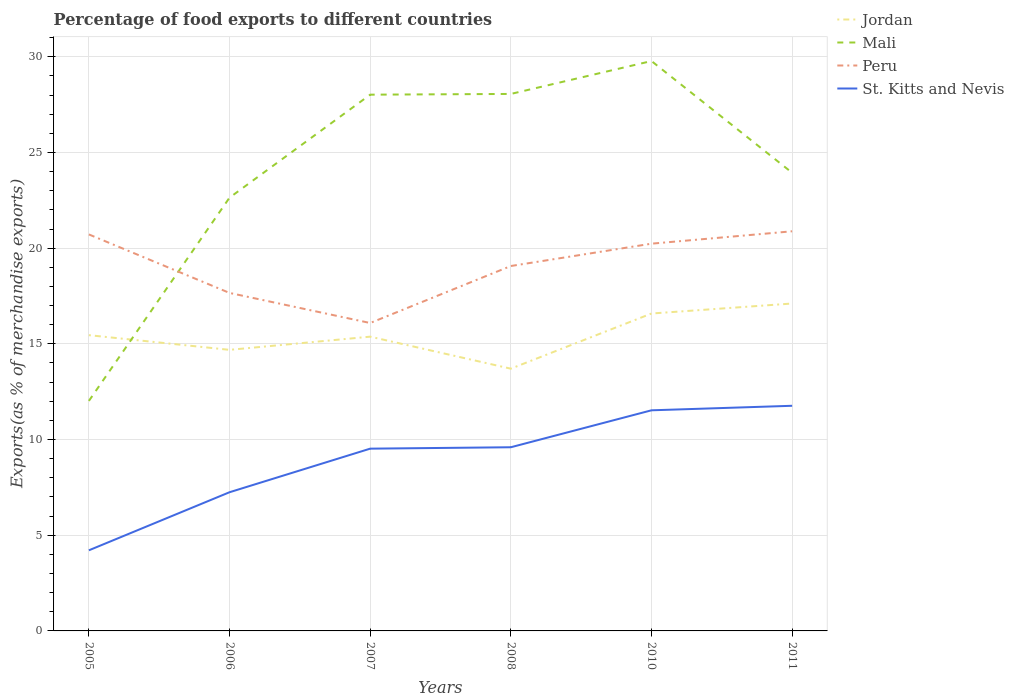How many different coloured lines are there?
Ensure brevity in your answer.  4. Is the number of lines equal to the number of legend labels?
Offer a very short reply. Yes. Across all years, what is the maximum percentage of exports to different countries in Peru?
Keep it short and to the point. 16.09. What is the total percentage of exports to different countries in Jordan in the graph?
Give a very brief answer. -0.69. What is the difference between the highest and the second highest percentage of exports to different countries in St. Kitts and Nevis?
Offer a terse response. 7.55. Does the graph contain any zero values?
Offer a terse response. No. Does the graph contain grids?
Your answer should be very brief. Yes. How are the legend labels stacked?
Provide a succinct answer. Vertical. What is the title of the graph?
Keep it short and to the point. Percentage of food exports to different countries. Does "Albania" appear as one of the legend labels in the graph?
Your answer should be compact. No. What is the label or title of the Y-axis?
Your answer should be compact. Exports(as % of merchandise exports). What is the Exports(as % of merchandise exports) in Jordan in 2005?
Provide a succinct answer. 15.45. What is the Exports(as % of merchandise exports) of Mali in 2005?
Provide a succinct answer. 12.02. What is the Exports(as % of merchandise exports) in Peru in 2005?
Offer a terse response. 20.72. What is the Exports(as % of merchandise exports) in St. Kitts and Nevis in 2005?
Provide a short and direct response. 4.21. What is the Exports(as % of merchandise exports) in Jordan in 2006?
Provide a short and direct response. 14.69. What is the Exports(as % of merchandise exports) in Mali in 2006?
Provide a succinct answer. 22.64. What is the Exports(as % of merchandise exports) of Peru in 2006?
Offer a terse response. 17.66. What is the Exports(as % of merchandise exports) in St. Kitts and Nevis in 2006?
Make the answer very short. 7.25. What is the Exports(as % of merchandise exports) of Jordan in 2007?
Offer a very short reply. 15.37. What is the Exports(as % of merchandise exports) in Mali in 2007?
Offer a terse response. 28.02. What is the Exports(as % of merchandise exports) in Peru in 2007?
Keep it short and to the point. 16.09. What is the Exports(as % of merchandise exports) in St. Kitts and Nevis in 2007?
Ensure brevity in your answer.  9.52. What is the Exports(as % of merchandise exports) in Jordan in 2008?
Provide a short and direct response. 13.7. What is the Exports(as % of merchandise exports) of Mali in 2008?
Your answer should be compact. 28.06. What is the Exports(as % of merchandise exports) in Peru in 2008?
Your response must be concise. 19.07. What is the Exports(as % of merchandise exports) in St. Kitts and Nevis in 2008?
Provide a short and direct response. 9.6. What is the Exports(as % of merchandise exports) of Jordan in 2010?
Offer a very short reply. 16.58. What is the Exports(as % of merchandise exports) in Mali in 2010?
Your response must be concise. 29.78. What is the Exports(as % of merchandise exports) in Peru in 2010?
Keep it short and to the point. 20.23. What is the Exports(as % of merchandise exports) in St. Kitts and Nevis in 2010?
Provide a short and direct response. 11.53. What is the Exports(as % of merchandise exports) in Jordan in 2011?
Keep it short and to the point. 17.11. What is the Exports(as % of merchandise exports) in Mali in 2011?
Your response must be concise. 23.94. What is the Exports(as % of merchandise exports) in Peru in 2011?
Offer a terse response. 20.88. What is the Exports(as % of merchandise exports) of St. Kitts and Nevis in 2011?
Give a very brief answer. 11.76. Across all years, what is the maximum Exports(as % of merchandise exports) of Jordan?
Ensure brevity in your answer.  17.11. Across all years, what is the maximum Exports(as % of merchandise exports) of Mali?
Provide a succinct answer. 29.78. Across all years, what is the maximum Exports(as % of merchandise exports) of Peru?
Keep it short and to the point. 20.88. Across all years, what is the maximum Exports(as % of merchandise exports) of St. Kitts and Nevis?
Your answer should be compact. 11.76. Across all years, what is the minimum Exports(as % of merchandise exports) of Jordan?
Provide a succinct answer. 13.7. Across all years, what is the minimum Exports(as % of merchandise exports) of Mali?
Ensure brevity in your answer.  12.02. Across all years, what is the minimum Exports(as % of merchandise exports) of Peru?
Offer a terse response. 16.09. Across all years, what is the minimum Exports(as % of merchandise exports) of St. Kitts and Nevis?
Your response must be concise. 4.21. What is the total Exports(as % of merchandise exports) in Jordan in the graph?
Your answer should be very brief. 92.91. What is the total Exports(as % of merchandise exports) of Mali in the graph?
Your answer should be very brief. 144.45. What is the total Exports(as % of merchandise exports) in Peru in the graph?
Your answer should be very brief. 114.65. What is the total Exports(as % of merchandise exports) in St. Kitts and Nevis in the graph?
Keep it short and to the point. 53.87. What is the difference between the Exports(as % of merchandise exports) of Jordan in 2005 and that in 2006?
Your answer should be very brief. 0.77. What is the difference between the Exports(as % of merchandise exports) of Mali in 2005 and that in 2006?
Your answer should be compact. -10.62. What is the difference between the Exports(as % of merchandise exports) of Peru in 2005 and that in 2006?
Keep it short and to the point. 3.06. What is the difference between the Exports(as % of merchandise exports) of St. Kitts and Nevis in 2005 and that in 2006?
Offer a terse response. -3.03. What is the difference between the Exports(as % of merchandise exports) in Jordan in 2005 and that in 2007?
Your response must be concise. 0.08. What is the difference between the Exports(as % of merchandise exports) in Mali in 2005 and that in 2007?
Make the answer very short. -16. What is the difference between the Exports(as % of merchandise exports) in Peru in 2005 and that in 2007?
Offer a very short reply. 4.63. What is the difference between the Exports(as % of merchandise exports) of St. Kitts and Nevis in 2005 and that in 2007?
Your answer should be compact. -5.31. What is the difference between the Exports(as % of merchandise exports) in Jordan in 2005 and that in 2008?
Provide a succinct answer. 1.75. What is the difference between the Exports(as % of merchandise exports) in Mali in 2005 and that in 2008?
Give a very brief answer. -16.04. What is the difference between the Exports(as % of merchandise exports) in Peru in 2005 and that in 2008?
Your answer should be very brief. 1.65. What is the difference between the Exports(as % of merchandise exports) in St. Kitts and Nevis in 2005 and that in 2008?
Make the answer very short. -5.38. What is the difference between the Exports(as % of merchandise exports) in Jordan in 2005 and that in 2010?
Your answer should be very brief. -1.13. What is the difference between the Exports(as % of merchandise exports) in Mali in 2005 and that in 2010?
Offer a terse response. -17.76. What is the difference between the Exports(as % of merchandise exports) in Peru in 2005 and that in 2010?
Your answer should be very brief. 0.48. What is the difference between the Exports(as % of merchandise exports) in St. Kitts and Nevis in 2005 and that in 2010?
Make the answer very short. -7.32. What is the difference between the Exports(as % of merchandise exports) in Jordan in 2005 and that in 2011?
Your response must be concise. -1.65. What is the difference between the Exports(as % of merchandise exports) of Mali in 2005 and that in 2011?
Offer a terse response. -11.92. What is the difference between the Exports(as % of merchandise exports) of Peru in 2005 and that in 2011?
Ensure brevity in your answer.  -0.16. What is the difference between the Exports(as % of merchandise exports) of St. Kitts and Nevis in 2005 and that in 2011?
Ensure brevity in your answer.  -7.55. What is the difference between the Exports(as % of merchandise exports) in Jordan in 2006 and that in 2007?
Your answer should be compact. -0.69. What is the difference between the Exports(as % of merchandise exports) of Mali in 2006 and that in 2007?
Offer a very short reply. -5.38. What is the difference between the Exports(as % of merchandise exports) in Peru in 2006 and that in 2007?
Offer a very short reply. 1.57. What is the difference between the Exports(as % of merchandise exports) of St. Kitts and Nevis in 2006 and that in 2007?
Offer a very short reply. -2.28. What is the difference between the Exports(as % of merchandise exports) in Jordan in 2006 and that in 2008?
Give a very brief answer. 0.98. What is the difference between the Exports(as % of merchandise exports) of Mali in 2006 and that in 2008?
Offer a very short reply. -5.42. What is the difference between the Exports(as % of merchandise exports) of Peru in 2006 and that in 2008?
Provide a succinct answer. -1.41. What is the difference between the Exports(as % of merchandise exports) of St. Kitts and Nevis in 2006 and that in 2008?
Your answer should be very brief. -2.35. What is the difference between the Exports(as % of merchandise exports) of Jordan in 2006 and that in 2010?
Offer a very short reply. -1.9. What is the difference between the Exports(as % of merchandise exports) of Mali in 2006 and that in 2010?
Provide a succinct answer. -7.14. What is the difference between the Exports(as % of merchandise exports) in Peru in 2006 and that in 2010?
Make the answer very short. -2.57. What is the difference between the Exports(as % of merchandise exports) of St. Kitts and Nevis in 2006 and that in 2010?
Provide a short and direct response. -4.28. What is the difference between the Exports(as % of merchandise exports) of Jordan in 2006 and that in 2011?
Give a very brief answer. -2.42. What is the difference between the Exports(as % of merchandise exports) of Mali in 2006 and that in 2011?
Offer a very short reply. -1.3. What is the difference between the Exports(as % of merchandise exports) of Peru in 2006 and that in 2011?
Your response must be concise. -3.22. What is the difference between the Exports(as % of merchandise exports) in St. Kitts and Nevis in 2006 and that in 2011?
Provide a short and direct response. -4.52. What is the difference between the Exports(as % of merchandise exports) of Jordan in 2007 and that in 2008?
Offer a very short reply. 1.67. What is the difference between the Exports(as % of merchandise exports) in Mali in 2007 and that in 2008?
Your answer should be very brief. -0.04. What is the difference between the Exports(as % of merchandise exports) of Peru in 2007 and that in 2008?
Give a very brief answer. -2.98. What is the difference between the Exports(as % of merchandise exports) in St. Kitts and Nevis in 2007 and that in 2008?
Ensure brevity in your answer.  -0.07. What is the difference between the Exports(as % of merchandise exports) in Jordan in 2007 and that in 2010?
Your answer should be very brief. -1.21. What is the difference between the Exports(as % of merchandise exports) in Mali in 2007 and that in 2010?
Provide a short and direct response. -1.76. What is the difference between the Exports(as % of merchandise exports) of Peru in 2007 and that in 2010?
Ensure brevity in your answer.  -4.14. What is the difference between the Exports(as % of merchandise exports) of St. Kitts and Nevis in 2007 and that in 2010?
Make the answer very short. -2. What is the difference between the Exports(as % of merchandise exports) of Jordan in 2007 and that in 2011?
Provide a short and direct response. -1.73. What is the difference between the Exports(as % of merchandise exports) in Mali in 2007 and that in 2011?
Make the answer very short. 4.08. What is the difference between the Exports(as % of merchandise exports) in Peru in 2007 and that in 2011?
Your answer should be very brief. -4.79. What is the difference between the Exports(as % of merchandise exports) in St. Kitts and Nevis in 2007 and that in 2011?
Provide a succinct answer. -2.24. What is the difference between the Exports(as % of merchandise exports) of Jordan in 2008 and that in 2010?
Provide a short and direct response. -2.88. What is the difference between the Exports(as % of merchandise exports) of Mali in 2008 and that in 2010?
Provide a short and direct response. -1.72. What is the difference between the Exports(as % of merchandise exports) in Peru in 2008 and that in 2010?
Provide a succinct answer. -1.17. What is the difference between the Exports(as % of merchandise exports) in St. Kitts and Nevis in 2008 and that in 2010?
Offer a terse response. -1.93. What is the difference between the Exports(as % of merchandise exports) in Jordan in 2008 and that in 2011?
Your answer should be compact. -3.4. What is the difference between the Exports(as % of merchandise exports) in Mali in 2008 and that in 2011?
Your response must be concise. 4.12. What is the difference between the Exports(as % of merchandise exports) in Peru in 2008 and that in 2011?
Your answer should be compact. -1.81. What is the difference between the Exports(as % of merchandise exports) in St. Kitts and Nevis in 2008 and that in 2011?
Your answer should be very brief. -2.17. What is the difference between the Exports(as % of merchandise exports) of Jordan in 2010 and that in 2011?
Ensure brevity in your answer.  -0.52. What is the difference between the Exports(as % of merchandise exports) in Mali in 2010 and that in 2011?
Provide a succinct answer. 5.84. What is the difference between the Exports(as % of merchandise exports) in Peru in 2010 and that in 2011?
Provide a short and direct response. -0.65. What is the difference between the Exports(as % of merchandise exports) in St. Kitts and Nevis in 2010 and that in 2011?
Your answer should be compact. -0.24. What is the difference between the Exports(as % of merchandise exports) of Jordan in 2005 and the Exports(as % of merchandise exports) of Mali in 2006?
Provide a succinct answer. -7.18. What is the difference between the Exports(as % of merchandise exports) in Jordan in 2005 and the Exports(as % of merchandise exports) in Peru in 2006?
Offer a terse response. -2.21. What is the difference between the Exports(as % of merchandise exports) of Jordan in 2005 and the Exports(as % of merchandise exports) of St. Kitts and Nevis in 2006?
Provide a succinct answer. 8.21. What is the difference between the Exports(as % of merchandise exports) in Mali in 2005 and the Exports(as % of merchandise exports) in Peru in 2006?
Your response must be concise. -5.64. What is the difference between the Exports(as % of merchandise exports) in Mali in 2005 and the Exports(as % of merchandise exports) in St. Kitts and Nevis in 2006?
Ensure brevity in your answer.  4.77. What is the difference between the Exports(as % of merchandise exports) in Peru in 2005 and the Exports(as % of merchandise exports) in St. Kitts and Nevis in 2006?
Offer a terse response. 13.47. What is the difference between the Exports(as % of merchandise exports) in Jordan in 2005 and the Exports(as % of merchandise exports) in Mali in 2007?
Keep it short and to the point. -12.57. What is the difference between the Exports(as % of merchandise exports) in Jordan in 2005 and the Exports(as % of merchandise exports) in Peru in 2007?
Give a very brief answer. -0.64. What is the difference between the Exports(as % of merchandise exports) of Jordan in 2005 and the Exports(as % of merchandise exports) of St. Kitts and Nevis in 2007?
Provide a short and direct response. 5.93. What is the difference between the Exports(as % of merchandise exports) of Mali in 2005 and the Exports(as % of merchandise exports) of Peru in 2007?
Provide a short and direct response. -4.07. What is the difference between the Exports(as % of merchandise exports) in Mali in 2005 and the Exports(as % of merchandise exports) in St. Kitts and Nevis in 2007?
Keep it short and to the point. 2.5. What is the difference between the Exports(as % of merchandise exports) in Peru in 2005 and the Exports(as % of merchandise exports) in St. Kitts and Nevis in 2007?
Provide a succinct answer. 11.19. What is the difference between the Exports(as % of merchandise exports) in Jordan in 2005 and the Exports(as % of merchandise exports) in Mali in 2008?
Ensure brevity in your answer.  -12.6. What is the difference between the Exports(as % of merchandise exports) of Jordan in 2005 and the Exports(as % of merchandise exports) of Peru in 2008?
Give a very brief answer. -3.61. What is the difference between the Exports(as % of merchandise exports) in Jordan in 2005 and the Exports(as % of merchandise exports) in St. Kitts and Nevis in 2008?
Ensure brevity in your answer.  5.86. What is the difference between the Exports(as % of merchandise exports) of Mali in 2005 and the Exports(as % of merchandise exports) of Peru in 2008?
Your response must be concise. -7.05. What is the difference between the Exports(as % of merchandise exports) of Mali in 2005 and the Exports(as % of merchandise exports) of St. Kitts and Nevis in 2008?
Your answer should be very brief. 2.42. What is the difference between the Exports(as % of merchandise exports) in Peru in 2005 and the Exports(as % of merchandise exports) in St. Kitts and Nevis in 2008?
Make the answer very short. 11.12. What is the difference between the Exports(as % of merchandise exports) in Jordan in 2005 and the Exports(as % of merchandise exports) in Mali in 2010?
Offer a very short reply. -14.32. What is the difference between the Exports(as % of merchandise exports) in Jordan in 2005 and the Exports(as % of merchandise exports) in Peru in 2010?
Make the answer very short. -4.78. What is the difference between the Exports(as % of merchandise exports) of Jordan in 2005 and the Exports(as % of merchandise exports) of St. Kitts and Nevis in 2010?
Make the answer very short. 3.93. What is the difference between the Exports(as % of merchandise exports) of Mali in 2005 and the Exports(as % of merchandise exports) of Peru in 2010?
Your answer should be very brief. -8.22. What is the difference between the Exports(as % of merchandise exports) of Mali in 2005 and the Exports(as % of merchandise exports) of St. Kitts and Nevis in 2010?
Give a very brief answer. 0.49. What is the difference between the Exports(as % of merchandise exports) of Peru in 2005 and the Exports(as % of merchandise exports) of St. Kitts and Nevis in 2010?
Give a very brief answer. 9.19. What is the difference between the Exports(as % of merchandise exports) in Jordan in 2005 and the Exports(as % of merchandise exports) in Mali in 2011?
Make the answer very short. -8.49. What is the difference between the Exports(as % of merchandise exports) in Jordan in 2005 and the Exports(as % of merchandise exports) in Peru in 2011?
Your answer should be very brief. -5.43. What is the difference between the Exports(as % of merchandise exports) of Jordan in 2005 and the Exports(as % of merchandise exports) of St. Kitts and Nevis in 2011?
Offer a very short reply. 3.69. What is the difference between the Exports(as % of merchandise exports) of Mali in 2005 and the Exports(as % of merchandise exports) of Peru in 2011?
Make the answer very short. -8.86. What is the difference between the Exports(as % of merchandise exports) in Mali in 2005 and the Exports(as % of merchandise exports) in St. Kitts and Nevis in 2011?
Provide a succinct answer. 0.25. What is the difference between the Exports(as % of merchandise exports) in Peru in 2005 and the Exports(as % of merchandise exports) in St. Kitts and Nevis in 2011?
Make the answer very short. 8.95. What is the difference between the Exports(as % of merchandise exports) of Jordan in 2006 and the Exports(as % of merchandise exports) of Mali in 2007?
Offer a terse response. -13.33. What is the difference between the Exports(as % of merchandise exports) in Jordan in 2006 and the Exports(as % of merchandise exports) in Peru in 2007?
Your response must be concise. -1.4. What is the difference between the Exports(as % of merchandise exports) in Jordan in 2006 and the Exports(as % of merchandise exports) in St. Kitts and Nevis in 2007?
Keep it short and to the point. 5.16. What is the difference between the Exports(as % of merchandise exports) of Mali in 2006 and the Exports(as % of merchandise exports) of Peru in 2007?
Your answer should be compact. 6.55. What is the difference between the Exports(as % of merchandise exports) in Mali in 2006 and the Exports(as % of merchandise exports) in St. Kitts and Nevis in 2007?
Make the answer very short. 13.12. What is the difference between the Exports(as % of merchandise exports) in Peru in 2006 and the Exports(as % of merchandise exports) in St. Kitts and Nevis in 2007?
Your response must be concise. 8.14. What is the difference between the Exports(as % of merchandise exports) of Jordan in 2006 and the Exports(as % of merchandise exports) of Mali in 2008?
Provide a short and direct response. -13.37. What is the difference between the Exports(as % of merchandise exports) in Jordan in 2006 and the Exports(as % of merchandise exports) in Peru in 2008?
Ensure brevity in your answer.  -4.38. What is the difference between the Exports(as % of merchandise exports) of Jordan in 2006 and the Exports(as % of merchandise exports) of St. Kitts and Nevis in 2008?
Offer a very short reply. 5.09. What is the difference between the Exports(as % of merchandise exports) of Mali in 2006 and the Exports(as % of merchandise exports) of Peru in 2008?
Provide a succinct answer. 3.57. What is the difference between the Exports(as % of merchandise exports) in Mali in 2006 and the Exports(as % of merchandise exports) in St. Kitts and Nevis in 2008?
Your answer should be compact. 13.04. What is the difference between the Exports(as % of merchandise exports) in Peru in 2006 and the Exports(as % of merchandise exports) in St. Kitts and Nevis in 2008?
Ensure brevity in your answer.  8.06. What is the difference between the Exports(as % of merchandise exports) of Jordan in 2006 and the Exports(as % of merchandise exports) of Mali in 2010?
Make the answer very short. -15.09. What is the difference between the Exports(as % of merchandise exports) of Jordan in 2006 and the Exports(as % of merchandise exports) of Peru in 2010?
Ensure brevity in your answer.  -5.55. What is the difference between the Exports(as % of merchandise exports) of Jordan in 2006 and the Exports(as % of merchandise exports) of St. Kitts and Nevis in 2010?
Ensure brevity in your answer.  3.16. What is the difference between the Exports(as % of merchandise exports) of Mali in 2006 and the Exports(as % of merchandise exports) of Peru in 2010?
Offer a very short reply. 2.4. What is the difference between the Exports(as % of merchandise exports) in Mali in 2006 and the Exports(as % of merchandise exports) in St. Kitts and Nevis in 2010?
Your answer should be very brief. 11.11. What is the difference between the Exports(as % of merchandise exports) in Peru in 2006 and the Exports(as % of merchandise exports) in St. Kitts and Nevis in 2010?
Your response must be concise. 6.13. What is the difference between the Exports(as % of merchandise exports) of Jordan in 2006 and the Exports(as % of merchandise exports) of Mali in 2011?
Provide a succinct answer. -9.25. What is the difference between the Exports(as % of merchandise exports) of Jordan in 2006 and the Exports(as % of merchandise exports) of Peru in 2011?
Ensure brevity in your answer.  -6.19. What is the difference between the Exports(as % of merchandise exports) in Jordan in 2006 and the Exports(as % of merchandise exports) in St. Kitts and Nevis in 2011?
Offer a very short reply. 2.92. What is the difference between the Exports(as % of merchandise exports) in Mali in 2006 and the Exports(as % of merchandise exports) in Peru in 2011?
Provide a succinct answer. 1.76. What is the difference between the Exports(as % of merchandise exports) in Mali in 2006 and the Exports(as % of merchandise exports) in St. Kitts and Nevis in 2011?
Provide a succinct answer. 10.87. What is the difference between the Exports(as % of merchandise exports) in Peru in 2006 and the Exports(as % of merchandise exports) in St. Kitts and Nevis in 2011?
Your answer should be compact. 5.9. What is the difference between the Exports(as % of merchandise exports) in Jordan in 2007 and the Exports(as % of merchandise exports) in Mali in 2008?
Keep it short and to the point. -12.68. What is the difference between the Exports(as % of merchandise exports) of Jordan in 2007 and the Exports(as % of merchandise exports) of Peru in 2008?
Ensure brevity in your answer.  -3.69. What is the difference between the Exports(as % of merchandise exports) of Jordan in 2007 and the Exports(as % of merchandise exports) of St. Kitts and Nevis in 2008?
Your answer should be very brief. 5.78. What is the difference between the Exports(as % of merchandise exports) in Mali in 2007 and the Exports(as % of merchandise exports) in Peru in 2008?
Your answer should be very brief. 8.95. What is the difference between the Exports(as % of merchandise exports) in Mali in 2007 and the Exports(as % of merchandise exports) in St. Kitts and Nevis in 2008?
Make the answer very short. 18.42. What is the difference between the Exports(as % of merchandise exports) of Peru in 2007 and the Exports(as % of merchandise exports) of St. Kitts and Nevis in 2008?
Offer a terse response. 6.49. What is the difference between the Exports(as % of merchandise exports) of Jordan in 2007 and the Exports(as % of merchandise exports) of Mali in 2010?
Make the answer very short. -14.4. What is the difference between the Exports(as % of merchandise exports) of Jordan in 2007 and the Exports(as % of merchandise exports) of Peru in 2010?
Your response must be concise. -4.86. What is the difference between the Exports(as % of merchandise exports) of Jordan in 2007 and the Exports(as % of merchandise exports) of St. Kitts and Nevis in 2010?
Ensure brevity in your answer.  3.85. What is the difference between the Exports(as % of merchandise exports) of Mali in 2007 and the Exports(as % of merchandise exports) of Peru in 2010?
Offer a terse response. 7.79. What is the difference between the Exports(as % of merchandise exports) of Mali in 2007 and the Exports(as % of merchandise exports) of St. Kitts and Nevis in 2010?
Provide a succinct answer. 16.49. What is the difference between the Exports(as % of merchandise exports) in Peru in 2007 and the Exports(as % of merchandise exports) in St. Kitts and Nevis in 2010?
Ensure brevity in your answer.  4.56. What is the difference between the Exports(as % of merchandise exports) of Jordan in 2007 and the Exports(as % of merchandise exports) of Mali in 2011?
Keep it short and to the point. -8.56. What is the difference between the Exports(as % of merchandise exports) of Jordan in 2007 and the Exports(as % of merchandise exports) of Peru in 2011?
Give a very brief answer. -5.51. What is the difference between the Exports(as % of merchandise exports) in Jordan in 2007 and the Exports(as % of merchandise exports) in St. Kitts and Nevis in 2011?
Provide a short and direct response. 3.61. What is the difference between the Exports(as % of merchandise exports) in Mali in 2007 and the Exports(as % of merchandise exports) in Peru in 2011?
Offer a terse response. 7.14. What is the difference between the Exports(as % of merchandise exports) in Mali in 2007 and the Exports(as % of merchandise exports) in St. Kitts and Nevis in 2011?
Provide a short and direct response. 16.26. What is the difference between the Exports(as % of merchandise exports) of Peru in 2007 and the Exports(as % of merchandise exports) of St. Kitts and Nevis in 2011?
Ensure brevity in your answer.  4.32. What is the difference between the Exports(as % of merchandise exports) in Jordan in 2008 and the Exports(as % of merchandise exports) in Mali in 2010?
Make the answer very short. -16.07. What is the difference between the Exports(as % of merchandise exports) in Jordan in 2008 and the Exports(as % of merchandise exports) in Peru in 2010?
Give a very brief answer. -6.53. What is the difference between the Exports(as % of merchandise exports) in Jordan in 2008 and the Exports(as % of merchandise exports) in St. Kitts and Nevis in 2010?
Offer a terse response. 2.18. What is the difference between the Exports(as % of merchandise exports) of Mali in 2008 and the Exports(as % of merchandise exports) of Peru in 2010?
Your response must be concise. 7.82. What is the difference between the Exports(as % of merchandise exports) in Mali in 2008 and the Exports(as % of merchandise exports) in St. Kitts and Nevis in 2010?
Your answer should be very brief. 16.53. What is the difference between the Exports(as % of merchandise exports) of Peru in 2008 and the Exports(as % of merchandise exports) of St. Kitts and Nevis in 2010?
Keep it short and to the point. 7.54. What is the difference between the Exports(as % of merchandise exports) in Jordan in 2008 and the Exports(as % of merchandise exports) in Mali in 2011?
Give a very brief answer. -10.24. What is the difference between the Exports(as % of merchandise exports) in Jordan in 2008 and the Exports(as % of merchandise exports) in Peru in 2011?
Your answer should be compact. -7.18. What is the difference between the Exports(as % of merchandise exports) of Jordan in 2008 and the Exports(as % of merchandise exports) of St. Kitts and Nevis in 2011?
Your answer should be compact. 1.94. What is the difference between the Exports(as % of merchandise exports) of Mali in 2008 and the Exports(as % of merchandise exports) of Peru in 2011?
Ensure brevity in your answer.  7.18. What is the difference between the Exports(as % of merchandise exports) in Mali in 2008 and the Exports(as % of merchandise exports) in St. Kitts and Nevis in 2011?
Ensure brevity in your answer.  16.29. What is the difference between the Exports(as % of merchandise exports) of Peru in 2008 and the Exports(as % of merchandise exports) of St. Kitts and Nevis in 2011?
Offer a terse response. 7.3. What is the difference between the Exports(as % of merchandise exports) in Jordan in 2010 and the Exports(as % of merchandise exports) in Mali in 2011?
Your answer should be compact. -7.35. What is the difference between the Exports(as % of merchandise exports) of Jordan in 2010 and the Exports(as % of merchandise exports) of Peru in 2011?
Give a very brief answer. -4.3. What is the difference between the Exports(as % of merchandise exports) of Jordan in 2010 and the Exports(as % of merchandise exports) of St. Kitts and Nevis in 2011?
Ensure brevity in your answer.  4.82. What is the difference between the Exports(as % of merchandise exports) in Mali in 2010 and the Exports(as % of merchandise exports) in Peru in 2011?
Your answer should be compact. 8.9. What is the difference between the Exports(as % of merchandise exports) of Mali in 2010 and the Exports(as % of merchandise exports) of St. Kitts and Nevis in 2011?
Provide a short and direct response. 18.01. What is the difference between the Exports(as % of merchandise exports) in Peru in 2010 and the Exports(as % of merchandise exports) in St. Kitts and Nevis in 2011?
Ensure brevity in your answer.  8.47. What is the average Exports(as % of merchandise exports) in Jordan per year?
Keep it short and to the point. 15.48. What is the average Exports(as % of merchandise exports) of Mali per year?
Offer a very short reply. 24.08. What is the average Exports(as % of merchandise exports) in Peru per year?
Provide a succinct answer. 19.11. What is the average Exports(as % of merchandise exports) of St. Kitts and Nevis per year?
Your answer should be compact. 8.98. In the year 2005, what is the difference between the Exports(as % of merchandise exports) of Jordan and Exports(as % of merchandise exports) of Mali?
Offer a terse response. 3.44. In the year 2005, what is the difference between the Exports(as % of merchandise exports) in Jordan and Exports(as % of merchandise exports) in Peru?
Make the answer very short. -5.26. In the year 2005, what is the difference between the Exports(as % of merchandise exports) of Jordan and Exports(as % of merchandise exports) of St. Kitts and Nevis?
Ensure brevity in your answer.  11.24. In the year 2005, what is the difference between the Exports(as % of merchandise exports) in Mali and Exports(as % of merchandise exports) in Peru?
Provide a succinct answer. -8.7. In the year 2005, what is the difference between the Exports(as % of merchandise exports) of Mali and Exports(as % of merchandise exports) of St. Kitts and Nevis?
Keep it short and to the point. 7.81. In the year 2005, what is the difference between the Exports(as % of merchandise exports) in Peru and Exports(as % of merchandise exports) in St. Kitts and Nevis?
Offer a terse response. 16.51. In the year 2006, what is the difference between the Exports(as % of merchandise exports) in Jordan and Exports(as % of merchandise exports) in Mali?
Your answer should be compact. -7.95. In the year 2006, what is the difference between the Exports(as % of merchandise exports) of Jordan and Exports(as % of merchandise exports) of Peru?
Keep it short and to the point. -2.97. In the year 2006, what is the difference between the Exports(as % of merchandise exports) of Jordan and Exports(as % of merchandise exports) of St. Kitts and Nevis?
Offer a very short reply. 7.44. In the year 2006, what is the difference between the Exports(as % of merchandise exports) in Mali and Exports(as % of merchandise exports) in Peru?
Keep it short and to the point. 4.98. In the year 2006, what is the difference between the Exports(as % of merchandise exports) of Mali and Exports(as % of merchandise exports) of St. Kitts and Nevis?
Offer a very short reply. 15.39. In the year 2006, what is the difference between the Exports(as % of merchandise exports) in Peru and Exports(as % of merchandise exports) in St. Kitts and Nevis?
Your answer should be very brief. 10.41. In the year 2007, what is the difference between the Exports(as % of merchandise exports) of Jordan and Exports(as % of merchandise exports) of Mali?
Offer a terse response. -12.64. In the year 2007, what is the difference between the Exports(as % of merchandise exports) of Jordan and Exports(as % of merchandise exports) of Peru?
Make the answer very short. -0.71. In the year 2007, what is the difference between the Exports(as % of merchandise exports) of Jordan and Exports(as % of merchandise exports) of St. Kitts and Nevis?
Make the answer very short. 5.85. In the year 2007, what is the difference between the Exports(as % of merchandise exports) of Mali and Exports(as % of merchandise exports) of Peru?
Give a very brief answer. 11.93. In the year 2007, what is the difference between the Exports(as % of merchandise exports) of Mali and Exports(as % of merchandise exports) of St. Kitts and Nevis?
Offer a very short reply. 18.5. In the year 2007, what is the difference between the Exports(as % of merchandise exports) in Peru and Exports(as % of merchandise exports) in St. Kitts and Nevis?
Provide a succinct answer. 6.57. In the year 2008, what is the difference between the Exports(as % of merchandise exports) in Jordan and Exports(as % of merchandise exports) in Mali?
Provide a short and direct response. -14.36. In the year 2008, what is the difference between the Exports(as % of merchandise exports) in Jordan and Exports(as % of merchandise exports) in Peru?
Give a very brief answer. -5.36. In the year 2008, what is the difference between the Exports(as % of merchandise exports) of Jordan and Exports(as % of merchandise exports) of St. Kitts and Nevis?
Keep it short and to the point. 4.11. In the year 2008, what is the difference between the Exports(as % of merchandise exports) in Mali and Exports(as % of merchandise exports) in Peru?
Provide a short and direct response. 8.99. In the year 2008, what is the difference between the Exports(as % of merchandise exports) in Mali and Exports(as % of merchandise exports) in St. Kitts and Nevis?
Give a very brief answer. 18.46. In the year 2008, what is the difference between the Exports(as % of merchandise exports) in Peru and Exports(as % of merchandise exports) in St. Kitts and Nevis?
Give a very brief answer. 9.47. In the year 2010, what is the difference between the Exports(as % of merchandise exports) in Jordan and Exports(as % of merchandise exports) in Mali?
Keep it short and to the point. -13.19. In the year 2010, what is the difference between the Exports(as % of merchandise exports) of Jordan and Exports(as % of merchandise exports) of Peru?
Offer a terse response. -3.65. In the year 2010, what is the difference between the Exports(as % of merchandise exports) in Jordan and Exports(as % of merchandise exports) in St. Kitts and Nevis?
Provide a short and direct response. 5.06. In the year 2010, what is the difference between the Exports(as % of merchandise exports) in Mali and Exports(as % of merchandise exports) in Peru?
Make the answer very short. 9.54. In the year 2010, what is the difference between the Exports(as % of merchandise exports) in Mali and Exports(as % of merchandise exports) in St. Kitts and Nevis?
Your response must be concise. 18.25. In the year 2010, what is the difference between the Exports(as % of merchandise exports) of Peru and Exports(as % of merchandise exports) of St. Kitts and Nevis?
Give a very brief answer. 8.71. In the year 2011, what is the difference between the Exports(as % of merchandise exports) in Jordan and Exports(as % of merchandise exports) in Mali?
Ensure brevity in your answer.  -6.83. In the year 2011, what is the difference between the Exports(as % of merchandise exports) in Jordan and Exports(as % of merchandise exports) in Peru?
Your answer should be very brief. -3.77. In the year 2011, what is the difference between the Exports(as % of merchandise exports) of Jordan and Exports(as % of merchandise exports) of St. Kitts and Nevis?
Your answer should be very brief. 5.34. In the year 2011, what is the difference between the Exports(as % of merchandise exports) in Mali and Exports(as % of merchandise exports) in Peru?
Your response must be concise. 3.06. In the year 2011, what is the difference between the Exports(as % of merchandise exports) in Mali and Exports(as % of merchandise exports) in St. Kitts and Nevis?
Offer a very short reply. 12.18. In the year 2011, what is the difference between the Exports(as % of merchandise exports) of Peru and Exports(as % of merchandise exports) of St. Kitts and Nevis?
Offer a terse response. 9.12. What is the ratio of the Exports(as % of merchandise exports) in Jordan in 2005 to that in 2006?
Your response must be concise. 1.05. What is the ratio of the Exports(as % of merchandise exports) in Mali in 2005 to that in 2006?
Make the answer very short. 0.53. What is the ratio of the Exports(as % of merchandise exports) in Peru in 2005 to that in 2006?
Ensure brevity in your answer.  1.17. What is the ratio of the Exports(as % of merchandise exports) in St. Kitts and Nevis in 2005 to that in 2006?
Your answer should be compact. 0.58. What is the ratio of the Exports(as % of merchandise exports) of Jordan in 2005 to that in 2007?
Give a very brief answer. 1.01. What is the ratio of the Exports(as % of merchandise exports) in Mali in 2005 to that in 2007?
Your response must be concise. 0.43. What is the ratio of the Exports(as % of merchandise exports) in Peru in 2005 to that in 2007?
Your response must be concise. 1.29. What is the ratio of the Exports(as % of merchandise exports) in St. Kitts and Nevis in 2005 to that in 2007?
Provide a short and direct response. 0.44. What is the ratio of the Exports(as % of merchandise exports) of Jordan in 2005 to that in 2008?
Your answer should be very brief. 1.13. What is the ratio of the Exports(as % of merchandise exports) in Mali in 2005 to that in 2008?
Your answer should be compact. 0.43. What is the ratio of the Exports(as % of merchandise exports) in Peru in 2005 to that in 2008?
Your answer should be very brief. 1.09. What is the ratio of the Exports(as % of merchandise exports) of St. Kitts and Nevis in 2005 to that in 2008?
Provide a succinct answer. 0.44. What is the ratio of the Exports(as % of merchandise exports) in Jordan in 2005 to that in 2010?
Provide a short and direct response. 0.93. What is the ratio of the Exports(as % of merchandise exports) in Mali in 2005 to that in 2010?
Offer a very short reply. 0.4. What is the ratio of the Exports(as % of merchandise exports) of Peru in 2005 to that in 2010?
Offer a terse response. 1.02. What is the ratio of the Exports(as % of merchandise exports) of St. Kitts and Nevis in 2005 to that in 2010?
Provide a short and direct response. 0.37. What is the ratio of the Exports(as % of merchandise exports) of Jordan in 2005 to that in 2011?
Keep it short and to the point. 0.9. What is the ratio of the Exports(as % of merchandise exports) of Mali in 2005 to that in 2011?
Provide a short and direct response. 0.5. What is the ratio of the Exports(as % of merchandise exports) of St. Kitts and Nevis in 2005 to that in 2011?
Offer a terse response. 0.36. What is the ratio of the Exports(as % of merchandise exports) of Jordan in 2006 to that in 2007?
Your answer should be very brief. 0.96. What is the ratio of the Exports(as % of merchandise exports) in Mali in 2006 to that in 2007?
Your response must be concise. 0.81. What is the ratio of the Exports(as % of merchandise exports) in Peru in 2006 to that in 2007?
Your answer should be very brief. 1.1. What is the ratio of the Exports(as % of merchandise exports) of St. Kitts and Nevis in 2006 to that in 2007?
Provide a succinct answer. 0.76. What is the ratio of the Exports(as % of merchandise exports) of Jordan in 2006 to that in 2008?
Make the answer very short. 1.07. What is the ratio of the Exports(as % of merchandise exports) in Mali in 2006 to that in 2008?
Provide a short and direct response. 0.81. What is the ratio of the Exports(as % of merchandise exports) of Peru in 2006 to that in 2008?
Keep it short and to the point. 0.93. What is the ratio of the Exports(as % of merchandise exports) in St. Kitts and Nevis in 2006 to that in 2008?
Ensure brevity in your answer.  0.76. What is the ratio of the Exports(as % of merchandise exports) of Jordan in 2006 to that in 2010?
Offer a terse response. 0.89. What is the ratio of the Exports(as % of merchandise exports) of Mali in 2006 to that in 2010?
Offer a very short reply. 0.76. What is the ratio of the Exports(as % of merchandise exports) of Peru in 2006 to that in 2010?
Offer a very short reply. 0.87. What is the ratio of the Exports(as % of merchandise exports) of St. Kitts and Nevis in 2006 to that in 2010?
Provide a succinct answer. 0.63. What is the ratio of the Exports(as % of merchandise exports) in Jordan in 2006 to that in 2011?
Keep it short and to the point. 0.86. What is the ratio of the Exports(as % of merchandise exports) of Mali in 2006 to that in 2011?
Make the answer very short. 0.95. What is the ratio of the Exports(as % of merchandise exports) of Peru in 2006 to that in 2011?
Provide a short and direct response. 0.85. What is the ratio of the Exports(as % of merchandise exports) in St. Kitts and Nevis in 2006 to that in 2011?
Your response must be concise. 0.62. What is the ratio of the Exports(as % of merchandise exports) in Jordan in 2007 to that in 2008?
Ensure brevity in your answer.  1.12. What is the ratio of the Exports(as % of merchandise exports) of Mali in 2007 to that in 2008?
Make the answer very short. 1. What is the ratio of the Exports(as % of merchandise exports) of Peru in 2007 to that in 2008?
Offer a very short reply. 0.84. What is the ratio of the Exports(as % of merchandise exports) of St. Kitts and Nevis in 2007 to that in 2008?
Offer a very short reply. 0.99. What is the ratio of the Exports(as % of merchandise exports) in Jordan in 2007 to that in 2010?
Make the answer very short. 0.93. What is the ratio of the Exports(as % of merchandise exports) in Mali in 2007 to that in 2010?
Ensure brevity in your answer.  0.94. What is the ratio of the Exports(as % of merchandise exports) of Peru in 2007 to that in 2010?
Your response must be concise. 0.8. What is the ratio of the Exports(as % of merchandise exports) of St. Kitts and Nevis in 2007 to that in 2010?
Your answer should be very brief. 0.83. What is the ratio of the Exports(as % of merchandise exports) of Jordan in 2007 to that in 2011?
Your response must be concise. 0.9. What is the ratio of the Exports(as % of merchandise exports) of Mali in 2007 to that in 2011?
Provide a short and direct response. 1.17. What is the ratio of the Exports(as % of merchandise exports) of Peru in 2007 to that in 2011?
Offer a very short reply. 0.77. What is the ratio of the Exports(as % of merchandise exports) in St. Kitts and Nevis in 2007 to that in 2011?
Offer a very short reply. 0.81. What is the ratio of the Exports(as % of merchandise exports) in Jordan in 2008 to that in 2010?
Ensure brevity in your answer.  0.83. What is the ratio of the Exports(as % of merchandise exports) of Mali in 2008 to that in 2010?
Provide a short and direct response. 0.94. What is the ratio of the Exports(as % of merchandise exports) in Peru in 2008 to that in 2010?
Your answer should be compact. 0.94. What is the ratio of the Exports(as % of merchandise exports) of St. Kitts and Nevis in 2008 to that in 2010?
Offer a very short reply. 0.83. What is the ratio of the Exports(as % of merchandise exports) of Jordan in 2008 to that in 2011?
Offer a terse response. 0.8. What is the ratio of the Exports(as % of merchandise exports) in Mali in 2008 to that in 2011?
Provide a short and direct response. 1.17. What is the ratio of the Exports(as % of merchandise exports) in Peru in 2008 to that in 2011?
Your response must be concise. 0.91. What is the ratio of the Exports(as % of merchandise exports) of St. Kitts and Nevis in 2008 to that in 2011?
Your response must be concise. 0.82. What is the ratio of the Exports(as % of merchandise exports) in Jordan in 2010 to that in 2011?
Keep it short and to the point. 0.97. What is the ratio of the Exports(as % of merchandise exports) of Mali in 2010 to that in 2011?
Your answer should be compact. 1.24. What is the ratio of the Exports(as % of merchandise exports) in St. Kitts and Nevis in 2010 to that in 2011?
Offer a very short reply. 0.98. What is the difference between the highest and the second highest Exports(as % of merchandise exports) in Jordan?
Provide a succinct answer. 0.52. What is the difference between the highest and the second highest Exports(as % of merchandise exports) in Mali?
Offer a terse response. 1.72. What is the difference between the highest and the second highest Exports(as % of merchandise exports) of Peru?
Give a very brief answer. 0.16. What is the difference between the highest and the second highest Exports(as % of merchandise exports) in St. Kitts and Nevis?
Ensure brevity in your answer.  0.24. What is the difference between the highest and the lowest Exports(as % of merchandise exports) in Jordan?
Provide a succinct answer. 3.4. What is the difference between the highest and the lowest Exports(as % of merchandise exports) in Mali?
Keep it short and to the point. 17.76. What is the difference between the highest and the lowest Exports(as % of merchandise exports) in Peru?
Your answer should be very brief. 4.79. What is the difference between the highest and the lowest Exports(as % of merchandise exports) of St. Kitts and Nevis?
Give a very brief answer. 7.55. 